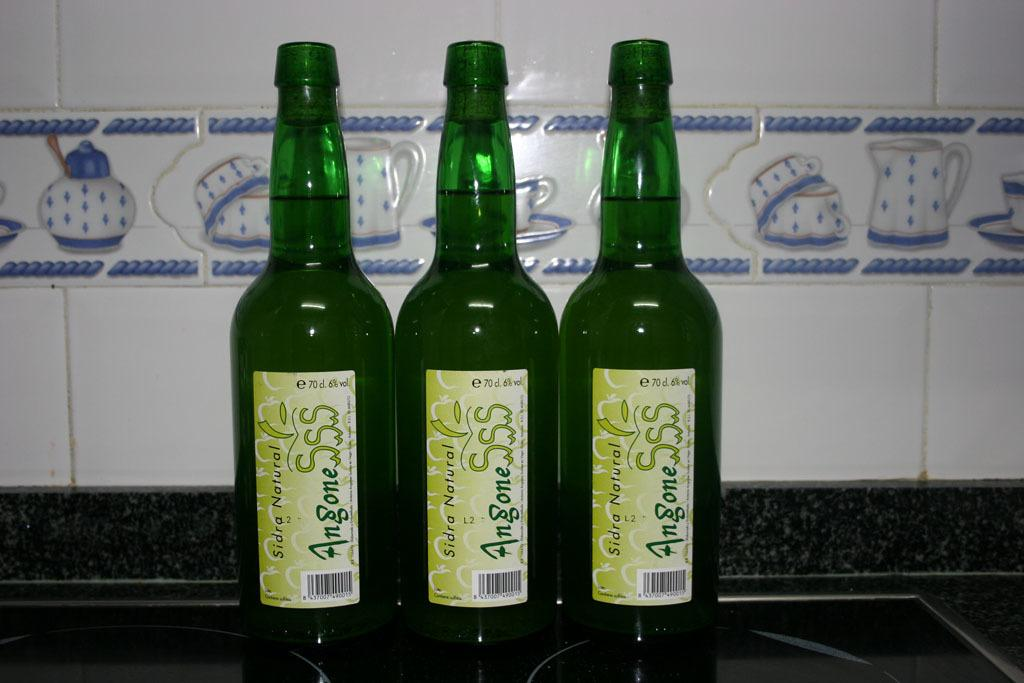<image>
Share a concise interpretation of the image provided. Three bottles of Sidra Natural beers next to one another. 